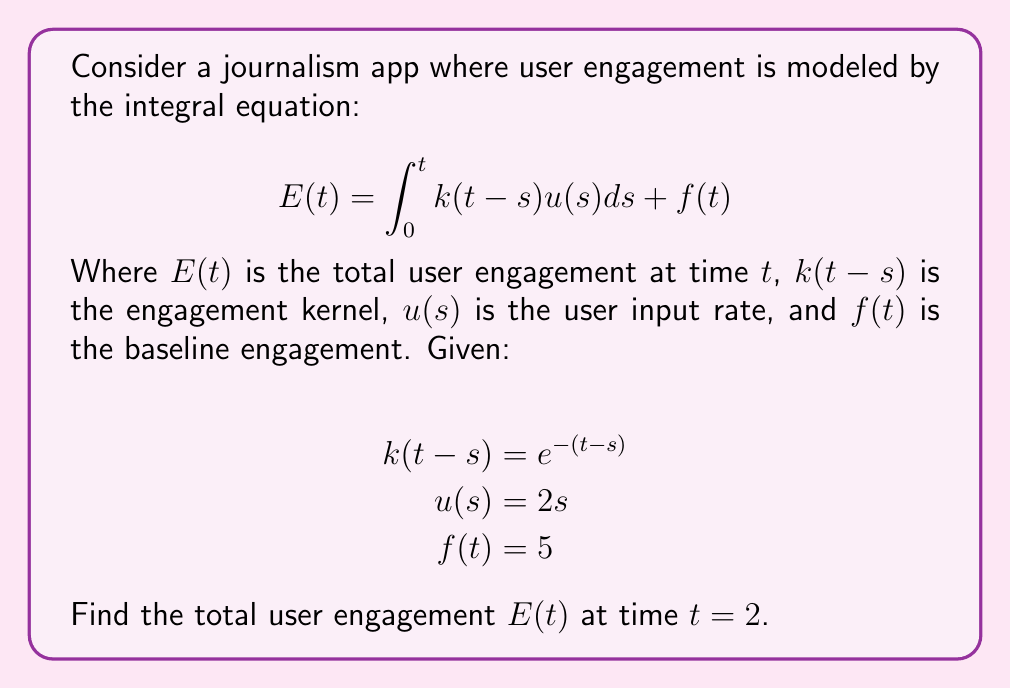Solve this math problem. To solve this integral equation, we'll follow these steps:

1) First, let's substitute the given functions into the integral equation:

   $$ E(2) = \int_0^2 e^{-(2-s)}(2s)ds + 5 $$

2) Let's focus on solving the integral:

   $$ \int_0^2 e^{-(2-s)}(2s)ds = 2\int_0^2 se^{-(2-s)}ds $$

3) To solve this, we can use integration by parts. Let $u=s$ and $dv=e^{-(2-s)}ds$:

   $$ 2\left[(-s)e^{-(2-s)}\Big|_0^2 + \int_0^2 e^{-(2-s)}ds\right] $$

4) Evaluate the first part:

   $$ 2\left[(-2)e^{-(2-2)} - (0)e^{-(2-0)} + \int_0^2 e^{-(2-s)}ds\right] $$
   $$ = 2\left[-2 - 0 + \int_0^2 e^{-(2-s)}ds\right] $$

5) Now solve the remaining integral:

   $$ \int_0^2 e^{-(2-s)}ds = -e^{-(2-s)}\Big|_0^2 = -(1 - e^{-2}) $$

6) Substituting back:

   $$ 2\left[-2 - (1 - e^{-2})\right] = -4 - 2 + 2e^{-2} = 2e^{-2} - 6 $$

7) Now, add this result to the baseline engagement $f(t) = 5$:

   $$ E(2) = (2e^{-2} - 6) + 5 = 2e^{-2} - 1 $$
Answer: $2e^{-2} - 1$ 